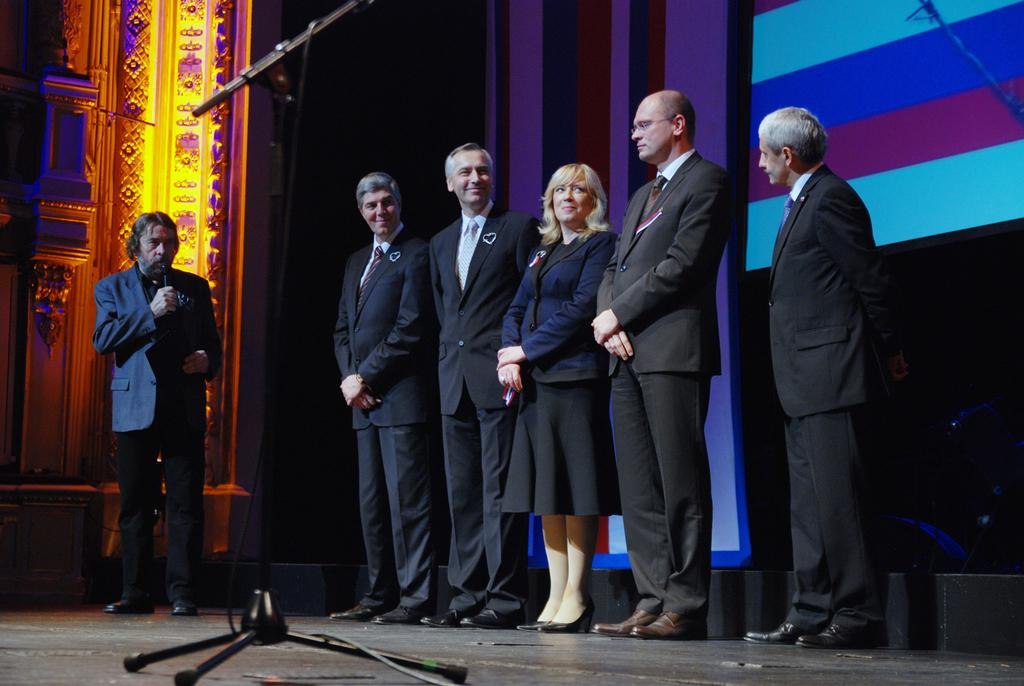How many people are in the image? There are people in the image, but the exact number is not specified. What is one person doing in the image? One person is holding and talking in the image. What can be seen in the background of the image? Cloth is visible in the background of the image. What object is present for amplifying sound? There is a mic stand in the image for amplifying sound. What architectural feature is present in the image? There is a pillar in the image. What type of furniture is being used by the army in the image? There is no mention of an army or furniture in the image. 